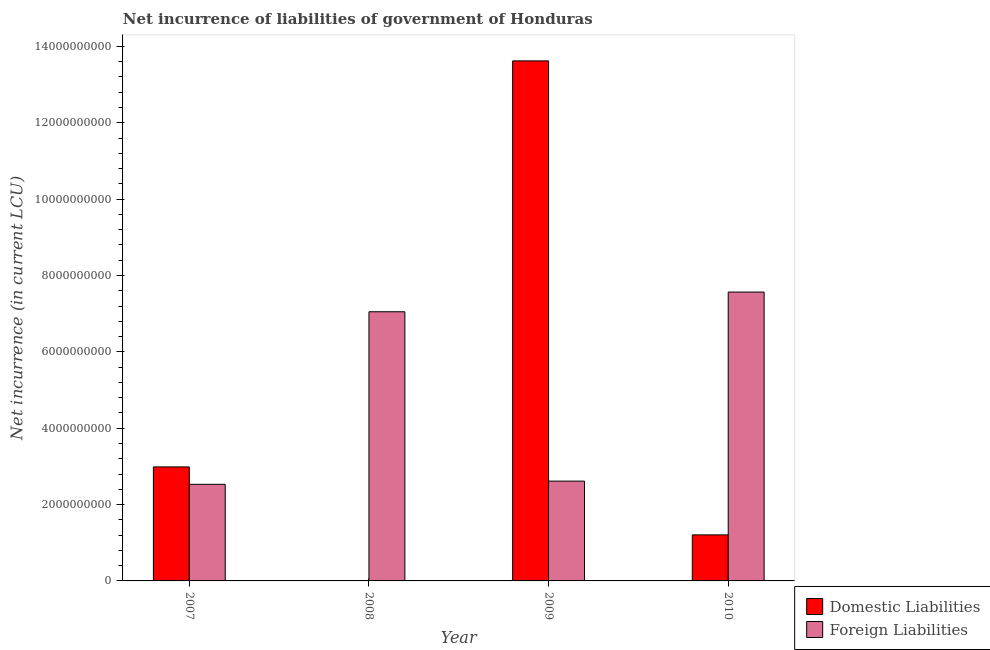How many different coloured bars are there?
Provide a short and direct response. 2. Are the number of bars per tick equal to the number of legend labels?
Your response must be concise. No. How many bars are there on the 2nd tick from the right?
Your answer should be very brief. 2. What is the net incurrence of foreign liabilities in 2007?
Ensure brevity in your answer.  2.53e+09. Across all years, what is the maximum net incurrence of domestic liabilities?
Give a very brief answer. 1.36e+1. What is the total net incurrence of foreign liabilities in the graph?
Your answer should be compact. 1.98e+1. What is the difference between the net incurrence of domestic liabilities in 2009 and that in 2010?
Offer a terse response. 1.24e+1. What is the difference between the net incurrence of domestic liabilities in 2008 and the net incurrence of foreign liabilities in 2009?
Offer a terse response. -1.36e+1. What is the average net incurrence of foreign liabilities per year?
Your response must be concise. 4.94e+09. In how many years, is the net incurrence of foreign liabilities greater than 6000000000 LCU?
Your response must be concise. 2. What is the ratio of the net incurrence of foreign liabilities in 2007 to that in 2008?
Give a very brief answer. 0.36. What is the difference between the highest and the second highest net incurrence of foreign liabilities?
Offer a terse response. 5.16e+08. What is the difference between the highest and the lowest net incurrence of foreign liabilities?
Keep it short and to the point. 5.04e+09. Is the sum of the net incurrence of foreign liabilities in 2009 and 2010 greater than the maximum net incurrence of domestic liabilities across all years?
Offer a very short reply. Yes. Are all the bars in the graph horizontal?
Make the answer very short. No. How many years are there in the graph?
Make the answer very short. 4. Does the graph contain any zero values?
Provide a short and direct response. Yes. Does the graph contain grids?
Make the answer very short. No. How many legend labels are there?
Give a very brief answer. 2. What is the title of the graph?
Provide a succinct answer. Net incurrence of liabilities of government of Honduras. Does "Urban" appear as one of the legend labels in the graph?
Offer a very short reply. No. What is the label or title of the X-axis?
Keep it short and to the point. Year. What is the label or title of the Y-axis?
Your answer should be compact. Net incurrence (in current LCU). What is the Net incurrence (in current LCU) of Domestic Liabilities in 2007?
Your response must be concise. 2.99e+09. What is the Net incurrence (in current LCU) in Foreign Liabilities in 2007?
Make the answer very short. 2.53e+09. What is the Net incurrence (in current LCU) in Domestic Liabilities in 2008?
Offer a very short reply. 0. What is the Net incurrence (in current LCU) of Foreign Liabilities in 2008?
Give a very brief answer. 7.05e+09. What is the Net incurrence (in current LCU) in Domestic Liabilities in 2009?
Make the answer very short. 1.36e+1. What is the Net incurrence (in current LCU) of Foreign Liabilities in 2009?
Offer a very short reply. 2.61e+09. What is the Net incurrence (in current LCU) of Domestic Liabilities in 2010?
Offer a terse response. 1.21e+09. What is the Net incurrence (in current LCU) in Foreign Liabilities in 2010?
Provide a succinct answer. 7.57e+09. Across all years, what is the maximum Net incurrence (in current LCU) in Domestic Liabilities?
Your answer should be compact. 1.36e+1. Across all years, what is the maximum Net incurrence (in current LCU) of Foreign Liabilities?
Make the answer very short. 7.57e+09. Across all years, what is the minimum Net incurrence (in current LCU) of Foreign Liabilities?
Your answer should be very brief. 2.53e+09. What is the total Net incurrence (in current LCU) of Domestic Liabilities in the graph?
Give a very brief answer. 1.78e+1. What is the total Net incurrence (in current LCU) in Foreign Liabilities in the graph?
Offer a very short reply. 1.98e+1. What is the difference between the Net incurrence (in current LCU) in Foreign Liabilities in 2007 and that in 2008?
Make the answer very short. -4.52e+09. What is the difference between the Net incurrence (in current LCU) of Domestic Liabilities in 2007 and that in 2009?
Provide a succinct answer. -1.06e+1. What is the difference between the Net incurrence (in current LCU) in Foreign Liabilities in 2007 and that in 2009?
Keep it short and to the point. -8.36e+07. What is the difference between the Net incurrence (in current LCU) in Domestic Liabilities in 2007 and that in 2010?
Make the answer very short. 1.78e+09. What is the difference between the Net incurrence (in current LCU) of Foreign Liabilities in 2007 and that in 2010?
Your answer should be compact. -5.04e+09. What is the difference between the Net incurrence (in current LCU) of Foreign Liabilities in 2008 and that in 2009?
Ensure brevity in your answer.  4.44e+09. What is the difference between the Net incurrence (in current LCU) of Foreign Liabilities in 2008 and that in 2010?
Make the answer very short. -5.16e+08. What is the difference between the Net incurrence (in current LCU) in Domestic Liabilities in 2009 and that in 2010?
Your answer should be compact. 1.24e+1. What is the difference between the Net incurrence (in current LCU) of Foreign Liabilities in 2009 and that in 2010?
Your answer should be very brief. -4.95e+09. What is the difference between the Net incurrence (in current LCU) of Domestic Liabilities in 2007 and the Net incurrence (in current LCU) of Foreign Liabilities in 2008?
Make the answer very short. -4.06e+09. What is the difference between the Net incurrence (in current LCU) in Domestic Liabilities in 2007 and the Net incurrence (in current LCU) in Foreign Liabilities in 2009?
Keep it short and to the point. 3.72e+08. What is the difference between the Net incurrence (in current LCU) of Domestic Liabilities in 2007 and the Net incurrence (in current LCU) of Foreign Liabilities in 2010?
Your answer should be compact. -4.58e+09. What is the difference between the Net incurrence (in current LCU) of Domestic Liabilities in 2009 and the Net incurrence (in current LCU) of Foreign Liabilities in 2010?
Make the answer very short. 6.06e+09. What is the average Net incurrence (in current LCU) of Domestic Liabilities per year?
Make the answer very short. 4.45e+09. What is the average Net incurrence (in current LCU) in Foreign Liabilities per year?
Ensure brevity in your answer.  4.94e+09. In the year 2007, what is the difference between the Net incurrence (in current LCU) of Domestic Liabilities and Net incurrence (in current LCU) of Foreign Liabilities?
Provide a short and direct response. 4.56e+08. In the year 2009, what is the difference between the Net incurrence (in current LCU) in Domestic Liabilities and Net incurrence (in current LCU) in Foreign Liabilities?
Keep it short and to the point. 1.10e+1. In the year 2010, what is the difference between the Net incurrence (in current LCU) in Domestic Liabilities and Net incurrence (in current LCU) in Foreign Liabilities?
Provide a succinct answer. -6.36e+09. What is the ratio of the Net incurrence (in current LCU) in Foreign Liabilities in 2007 to that in 2008?
Offer a terse response. 0.36. What is the ratio of the Net incurrence (in current LCU) of Domestic Liabilities in 2007 to that in 2009?
Your answer should be compact. 0.22. What is the ratio of the Net incurrence (in current LCU) in Foreign Liabilities in 2007 to that in 2009?
Offer a very short reply. 0.97. What is the ratio of the Net incurrence (in current LCU) of Domestic Liabilities in 2007 to that in 2010?
Offer a terse response. 2.48. What is the ratio of the Net incurrence (in current LCU) in Foreign Liabilities in 2007 to that in 2010?
Ensure brevity in your answer.  0.33. What is the ratio of the Net incurrence (in current LCU) of Foreign Liabilities in 2008 to that in 2009?
Make the answer very short. 2.7. What is the ratio of the Net incurrence (in current LCU) in Foreign Liabilities in 2008 to that in 2010?
Offer a terse response. 0.93. What is the ratio of the Net incurrence (in current LCU) of Domestic Liabilities in 2009 to that in 2010?
Your answer should be compact. 11.3. What is the ratio of the Net incurrence (in current LCU) of Foreign Liabilities in 2009 to that in 2010?
Your response must be concise. 0.35. What is the difference between the highest and the second highest Net incurrence (in current LCU) of Domestic Liabilities?
Offer a terse response. 1.06e+1. What is the difference between the highest and the second highest Net incurrence (in current LCU) of Foreign Liabilities?
Provide a short and direct response. 5.16e+08. What is the difference between the highest and the lowest Net incurrence (in current LCU) in Domestic Liabilities?
Your response must be concise. 1.36e+1. What is the difference between the highest and the lowest Net incurrence (in current LCU) in Foreign Liabilities?
Provide a succinct answer. 5.04e+09. 